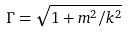<formula> <loc_0><loc_0><loc_500><loc_500>\Gamma = \sqrt { 1 + m ^ { 2 } / k ^ { 2 } }</formula> 